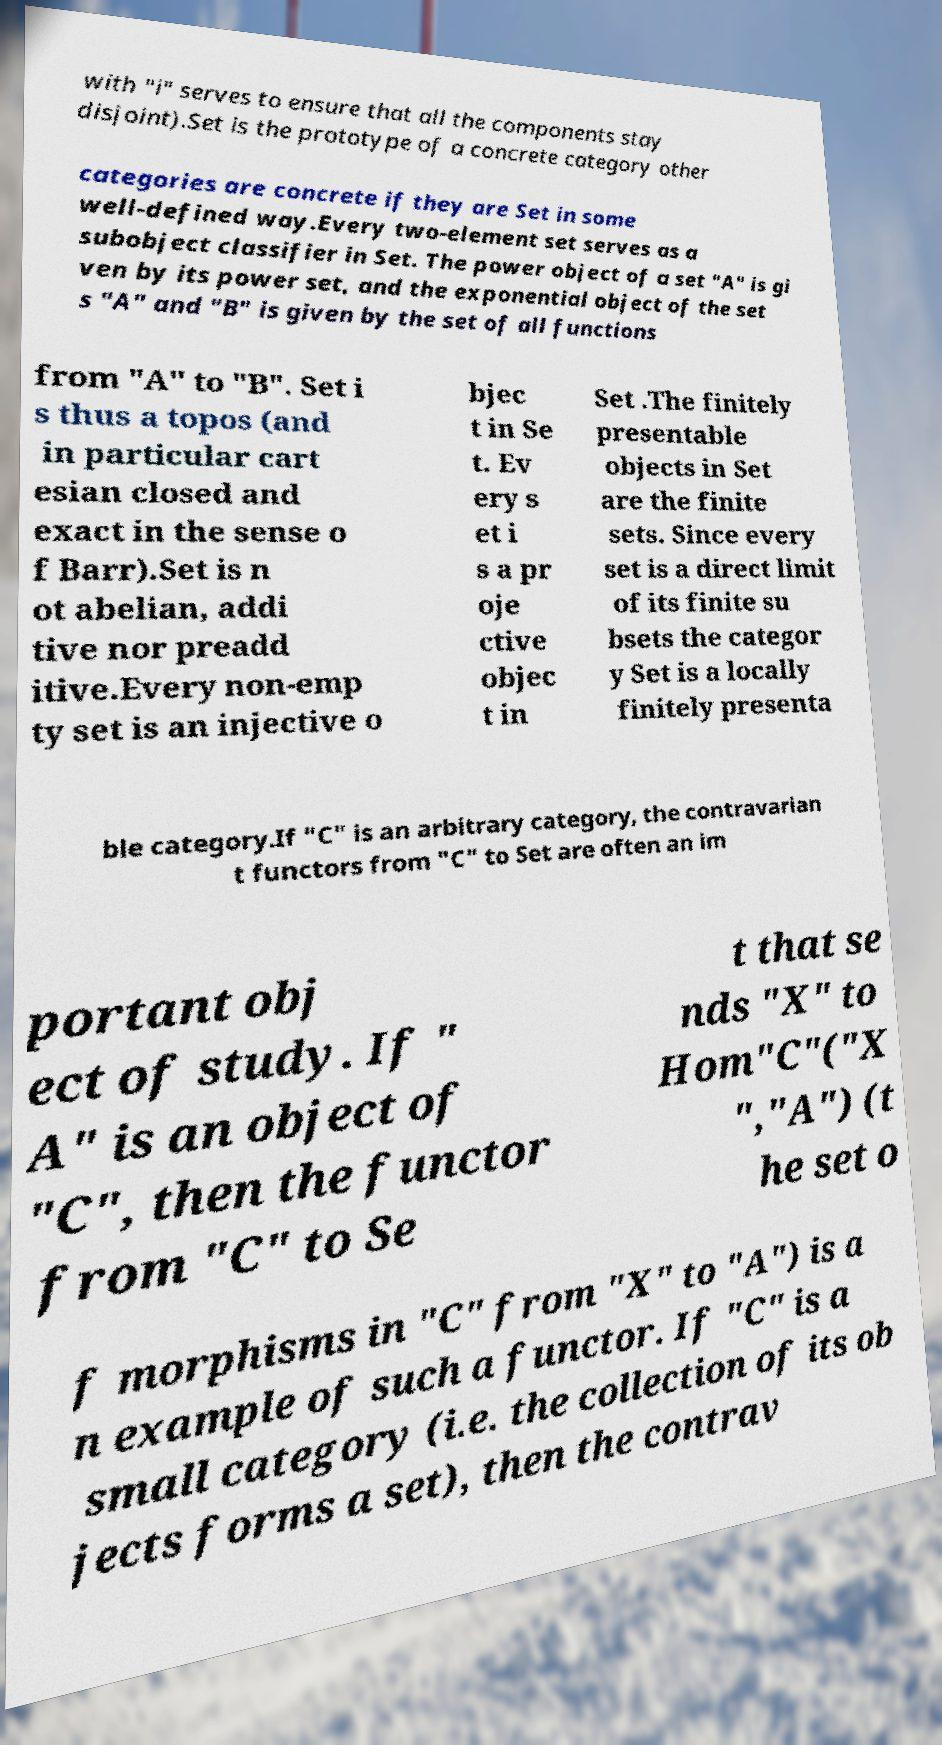Can you read and provide the text displayed in the image?This photo seems to have some interesting text. Can you extract and type it out for me? with "i" serves to ensure that all the components stay disjoint).Set is the prototype of a concrete category other categories are concrete if they are Set in some well-defined way.Every two-element set serves as a subobject classifier in Set. The power object of a set "A" is gi ven by its power set, and the exponential object of the set s "A" and "B" is given by the set of all functions from "A" to "B". Set i s thus a topos (and in particular cart esian closed and exact in the sense o f Barr).Set is n ot abelian, addi tive nor preadd itive.Every non-emp ty set is an injective o bjec t in Se t. Ev ery s et i s a pr oje ctive objec t in Set .The finitely presentable objects in Set are the finite sets. Since every set is a direct limit of its finite su bsets the categor y Set is a locally finitely presenta ble category.If "C" is an arbitrary category, the contravarian t functors from "C" to Set are often an im portant obj ect of study. If " A" is an object of "C", then the functor from "C" to Se t that se nds "X" to Hom"C"("X ","A") (t he set o f morphisms in "C" from "X" to "A") is a n example of such a functor. If "C" is a small category (i.e. the collection of its ob jects forms a set), then the contrav 